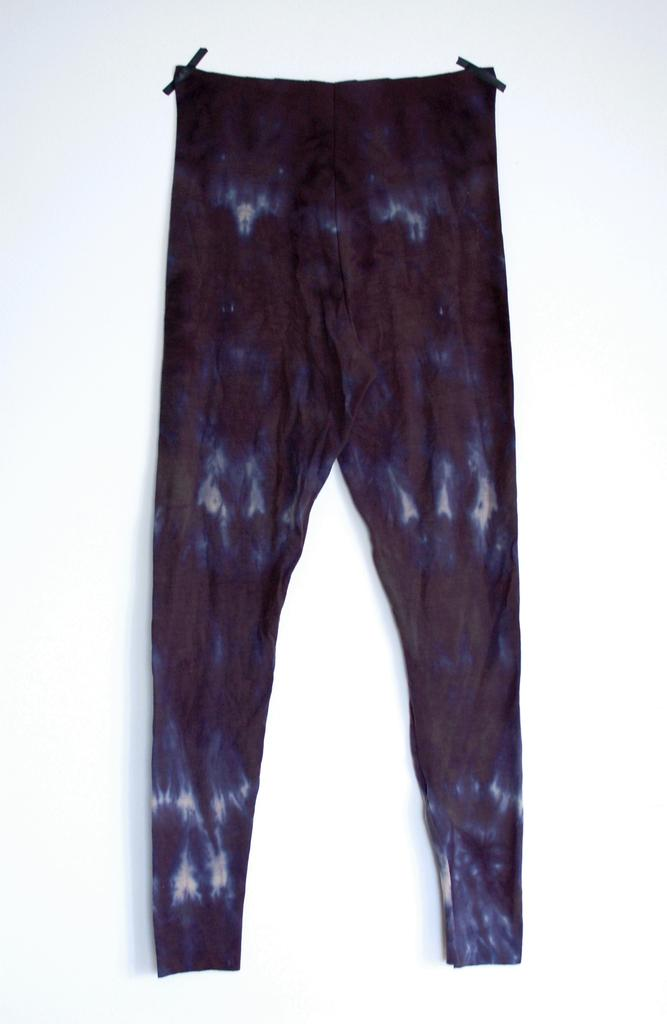What type of clothing item is in the image? There is a black pant in the image. Where is the black pant located? The black pant is on a white wall. What is the current interest rate on the black pant in the image? There is no mention of interest rates in the image, as it features a black pant on a white wall. 